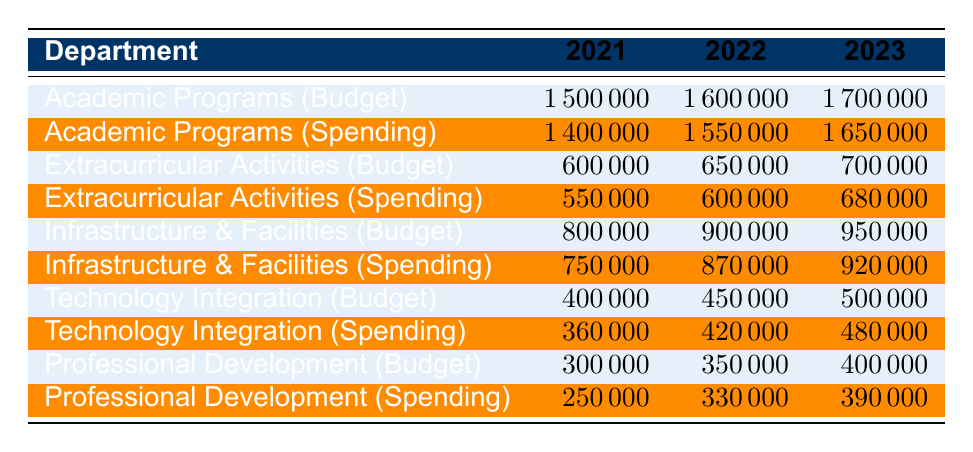What was the budget for Extracurricular Activities in 2022? Referring to the table, the budget for Extracurricular Activities in 2022 is listed under the column for that year, which shows 650000.
Answer: 650000 What was the spending for Professional Development in 2021? Looking at the 2021 row under Professional Development, the spending amount is 250000.
Answer: 250000 Which department had the highest budget in 2023? By comparing all budgets listed for each department in 2023, Academic Programs has the highest budget at 1700000.
Answer: Academic Programs What is the total budget allocated for Technology Integration over the three years? To find the total budget for Technology Integration, we sum the budgets from each year: 400000 (2021) + 450000 (2022) + 500000 (2023) = 1350000.
Answer: 1350000 Did the spending for Infrastructure & Facilities exceed the budget in any year? Checking the spending against the budget for each year, in all three years (2021: 750000 vs 800000, 2022: 870000 vs 900000, 2023: 920000 vs 950000), spending did not exceed the budget.
Answer: No What is the average spending for Extracurricular Activities over the three years? To calculate the average spending, we take the total spending: (550000 + 600000 + 680000) = 1830000 and divide by 3, resulting in an average of 610000.
Answer: 610000 Which year saw the largest increase in the budget for Academic Programs? By looking at the budgets, we see the changes: from 1500000 in 2021 to 1600000 in 2022 is an increase of 100000, and from 1600000 to 1700000 in 2023 is also an increase of 100000. Thus, the largest increase is the same for both years.
Answer: No increase was larger Was there any year when the spending on Technology Integration was less than 90% of the budget? Checking the percentages: In 2021, spending was 90% of the budget (360000 vs 400000), in 2022 it was 93.33% (420000 vs 450000), and in 2023 it was 96% (480000 vs 500000). Therefore, spending did not drop below 90%.
Answer: No 